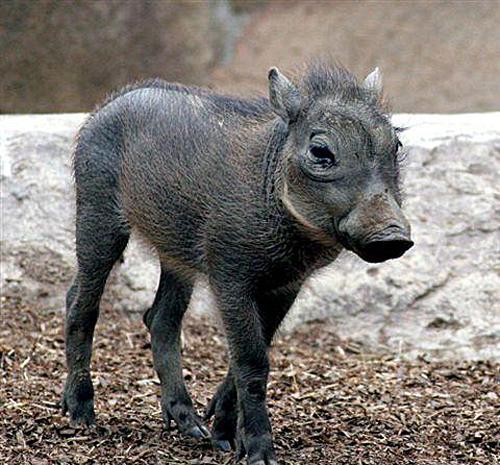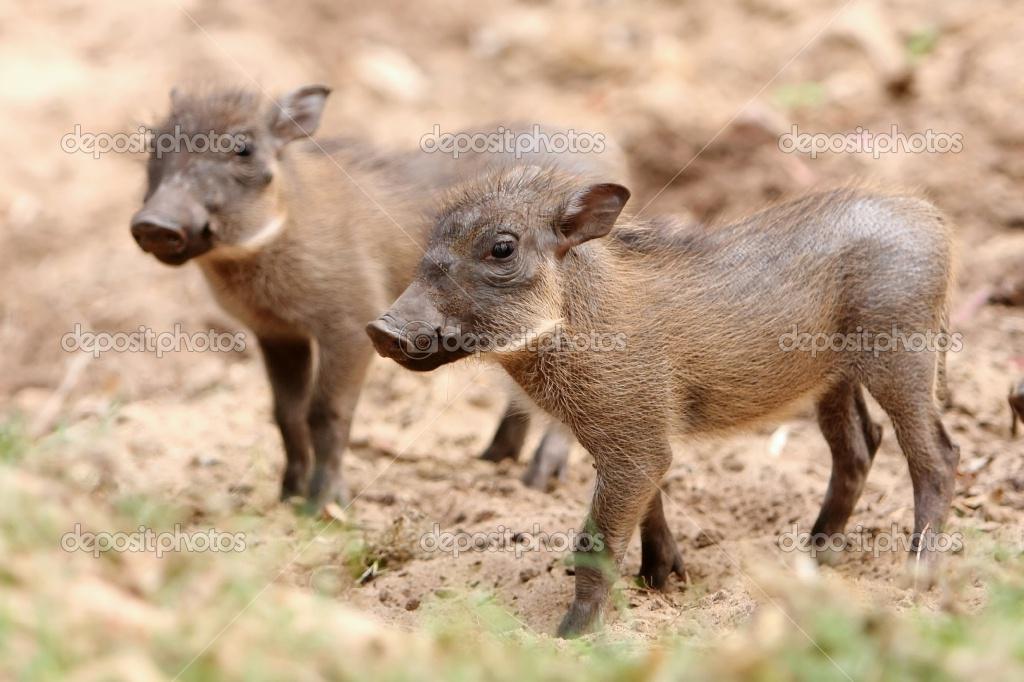The first image is the image on the left, the second image is the image on the right. Examine the images to the left and right. Is the description "The lefthand image contains one young warthog, and the righthand image contains two young warthogs." accurate? Answer yes or no. Yes. The first image is the image on the left, the second image is the image on the right. Evaluate the accuracy of this statement regarding the images: "There are two hogs facing each other in one of the images.". Is it true? Answer yes or no. No. 